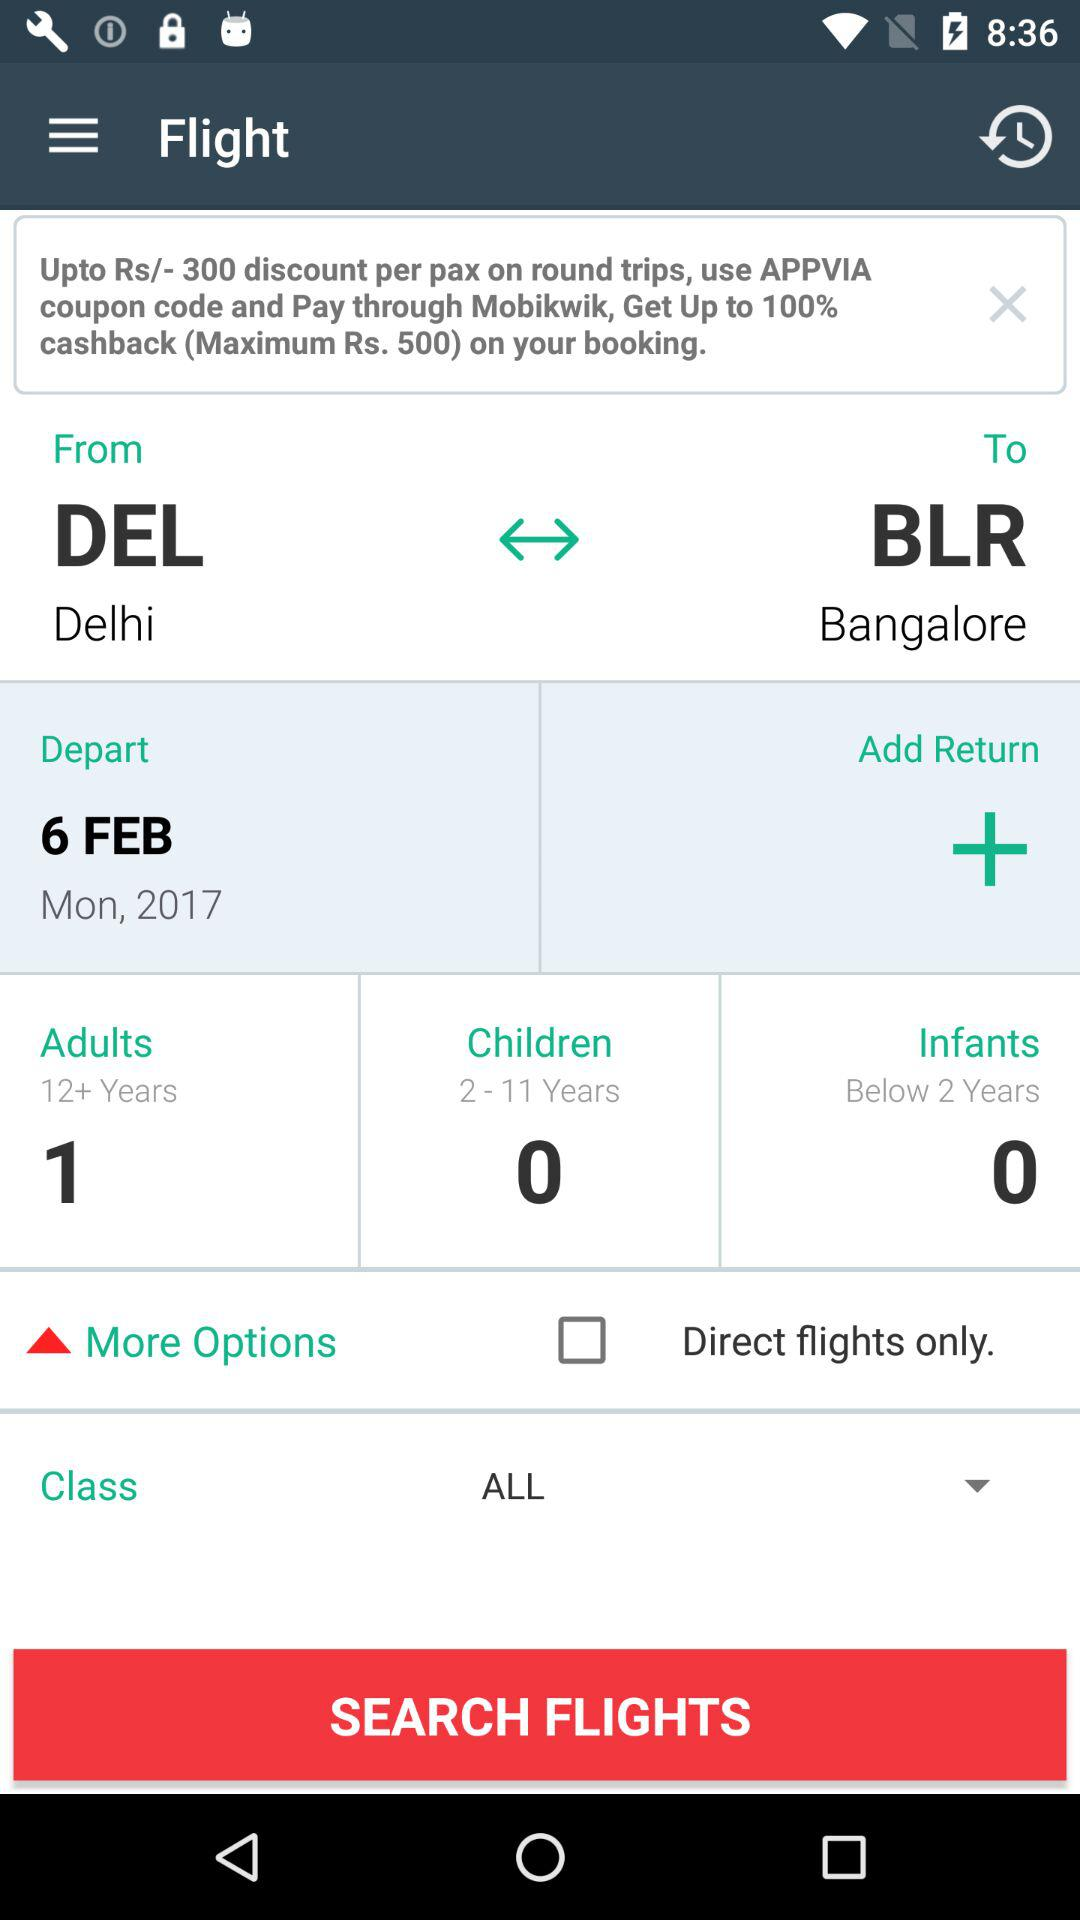How many adults are there? There is 1 adult. 